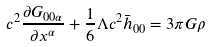<formula> <loc_0><loc_0><loc_500><loc_500>c ^ { 2 } \frac { \partial G _ { 0 0 \alpha } } { \partial x ^ { \alpha } } + \frac { 1 } { 6 } \Lambda c ^ { 2 } \bar { h } _ { 0 0 } = 3 \pi G \rho</formula> 